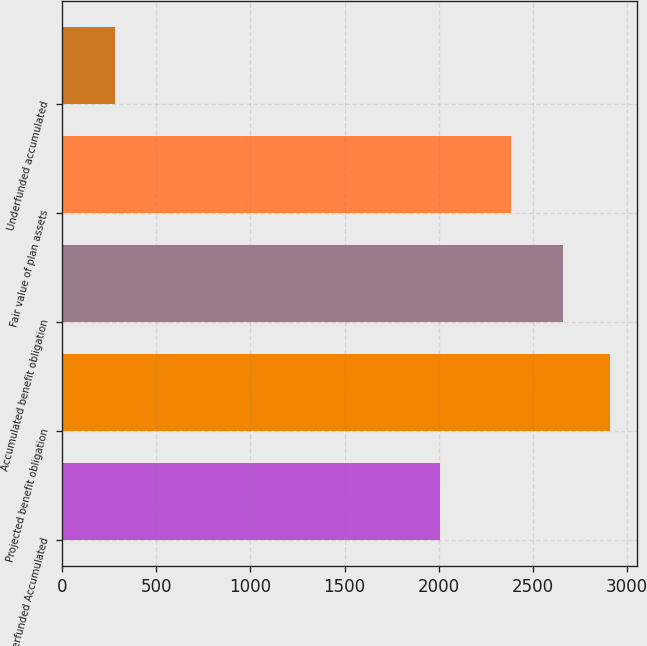<chart> <loc_0><loc_0><loc_500><loc_500><bar_chart><fcel>Underfunded Accumulated<fcel>Projected benefit obligation<fcel>Accumulated benefit obligation<fcel>Fair value of plan assets<fcel>Underfunded accumulated<nl><fcel>2010<fcel>2909.3<fcel>2663<fcel>2385<fcel>278<nl></chart> 